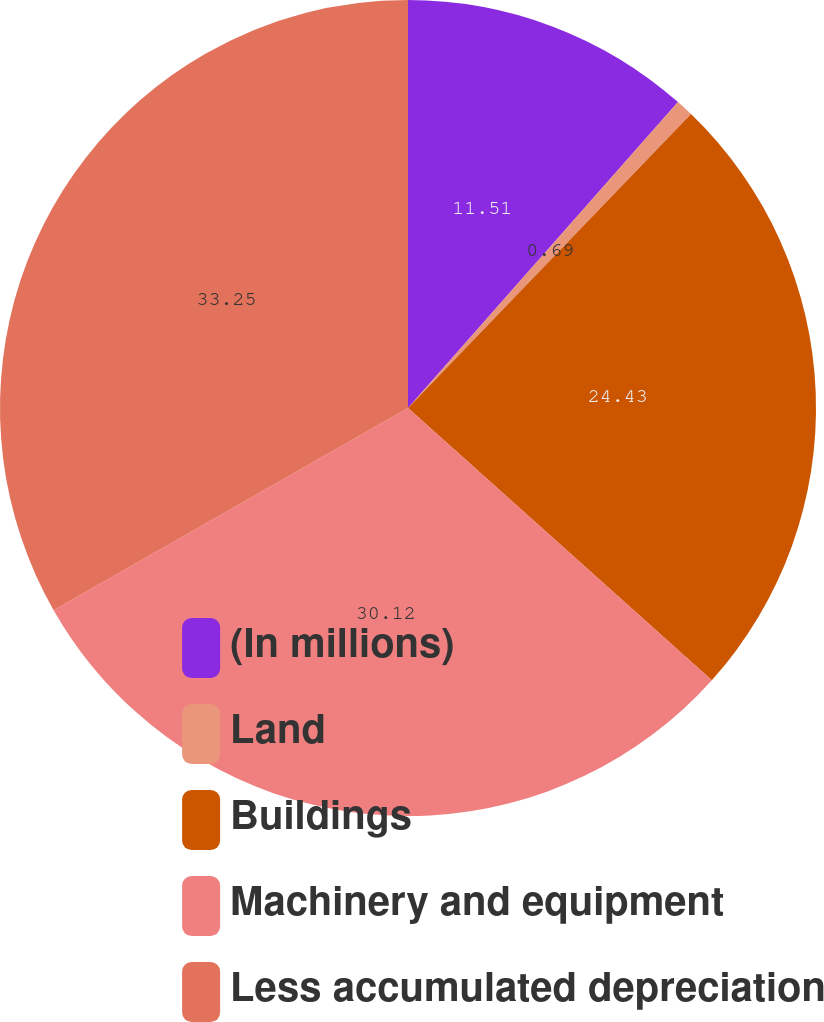Convert chart. <chart><loc_0><loc_0><loc_500><loc_500><pie_chart><fcel>(In millions)<fcel>Land<fcel>Buildings<fcel>Machinery and equipment<fcel>Less accumulated depreciation<nl><fcel>11.51%<fcel>0.69%<fcel>24.43%<fcel>30.12%<fcel>33.25%<nl></chart> 